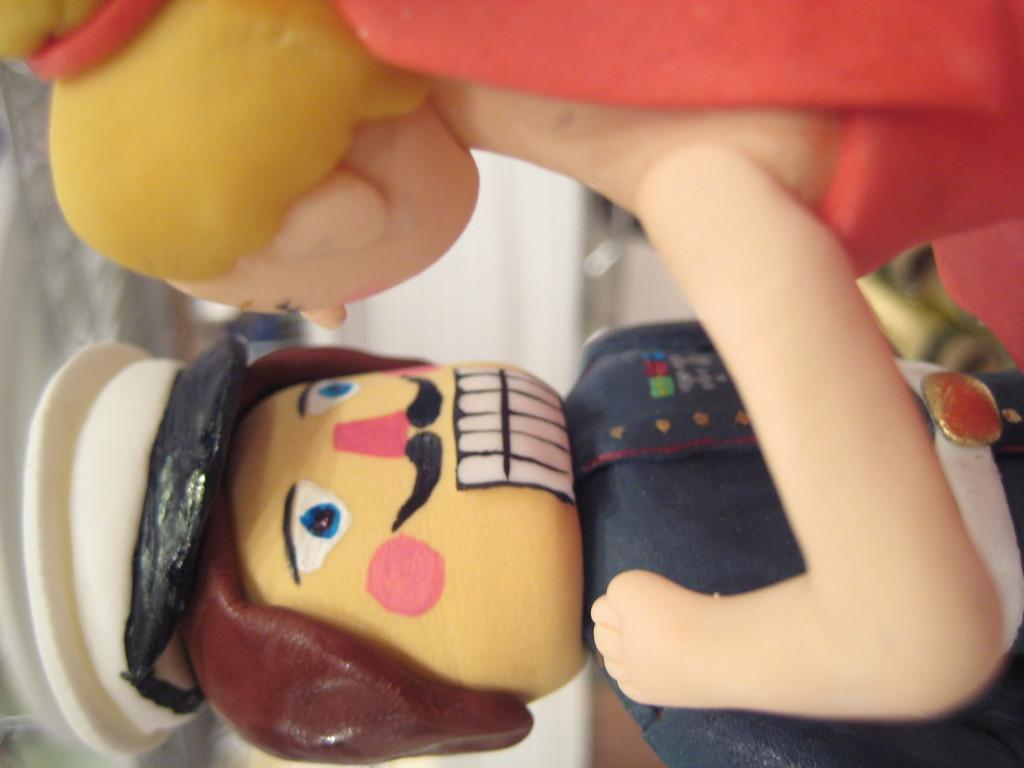How many dolls are present in the image? There are two dolls in the image. What are the dolls doing in the image? One doll is touching the other doll's hand. What is the appearance of one of the dolls? One of the dolls is dressed in a police uniform. What is the title of the book that the dolls are reading in the image? There is no book present in the image, so there is no title to reference. 